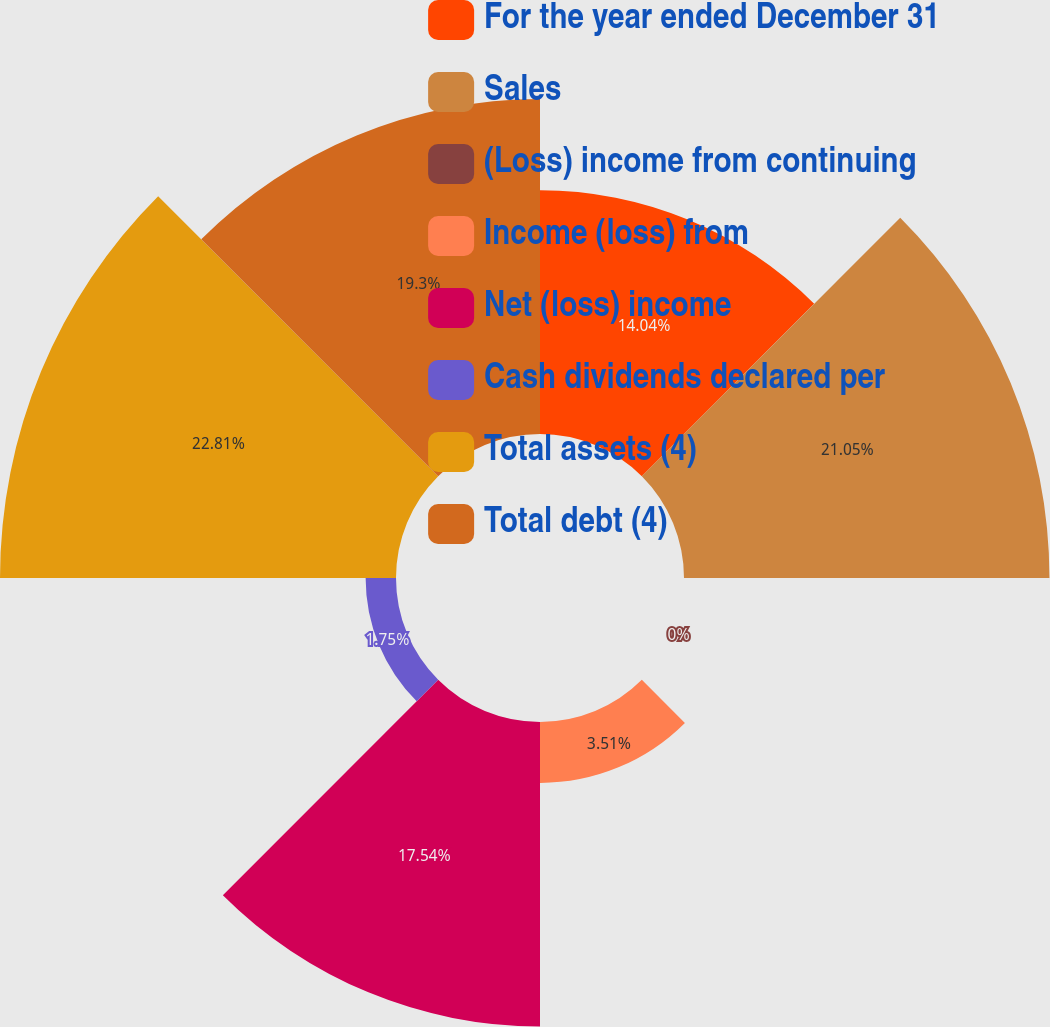Convert chart to OTSL. <chart><loc_0><loc_0><loc_500><loc_500><pie_chart><fcel>For the year ended December 31<fcel>Sales<fcel>(Loss) income from continuing<fcel>Income (loss) from<fcel>Net (loss) income<fcel>Cash dividends declared per<fcel>Total assets (4)<fcel>Total debt (4)<nl><fcel>14.04%<fcel>21.05%<fcel>0.0%<fcel>3.51%<fcel>17.54%<fcel>1.75%<fcel>22.81%<fcel>19.3%<nl></chart> 